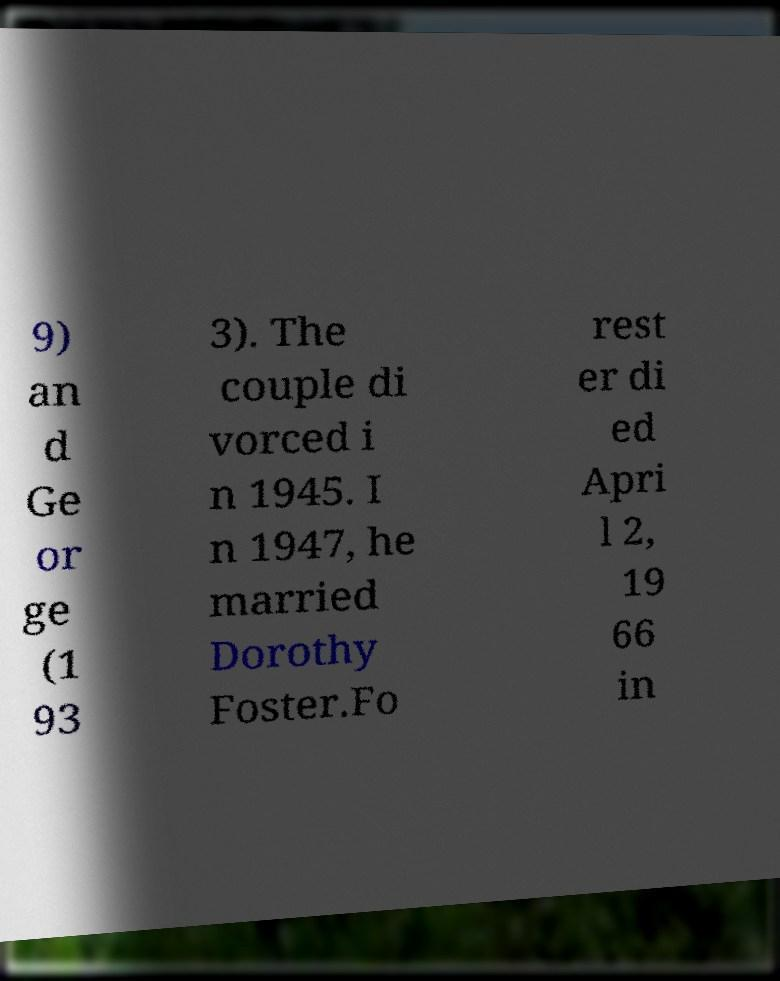I need the written content from this picture converted into text. Can you do that? 9) an d Ge or ge (1 93 3). The couple di vorced i n 1945. I n 1947, he married Dorothy Foster.Fo rest er di ed Apri l 2, 19 66 in 